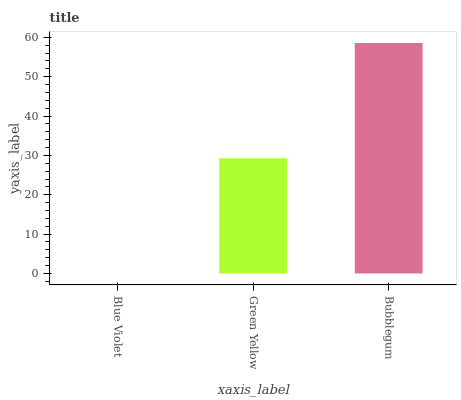Is Blue Violet the minimum?
Answer yes or no. Yes. Is Bubblegum the maximum?
Answer yes or no. Yes. Is Green Yellow the minimum?
Answer yes or no. No. Is Green Yellow the maximum?
Answer yes or no. No. Is Green Yellow greater than Blue Violet?
Answer yes or no. Yes. Is Blue Violet less than Green Yellow?
Answer yes or no. Yes. Is Blue Violet greater than Green Yellow?
Answer yes or no. No. Is Green Yellow less than Blue Violet?
Answer yes or no. No. Is Green Yellow the high median?
Answer yes or no. Yes. Is Green Yellow the low median?
Answer yes or no. Yes. Is Blue Violet the high median?
Answer yes or no. No. Is Blue Violet the low median?
Answer yes or no. No. 